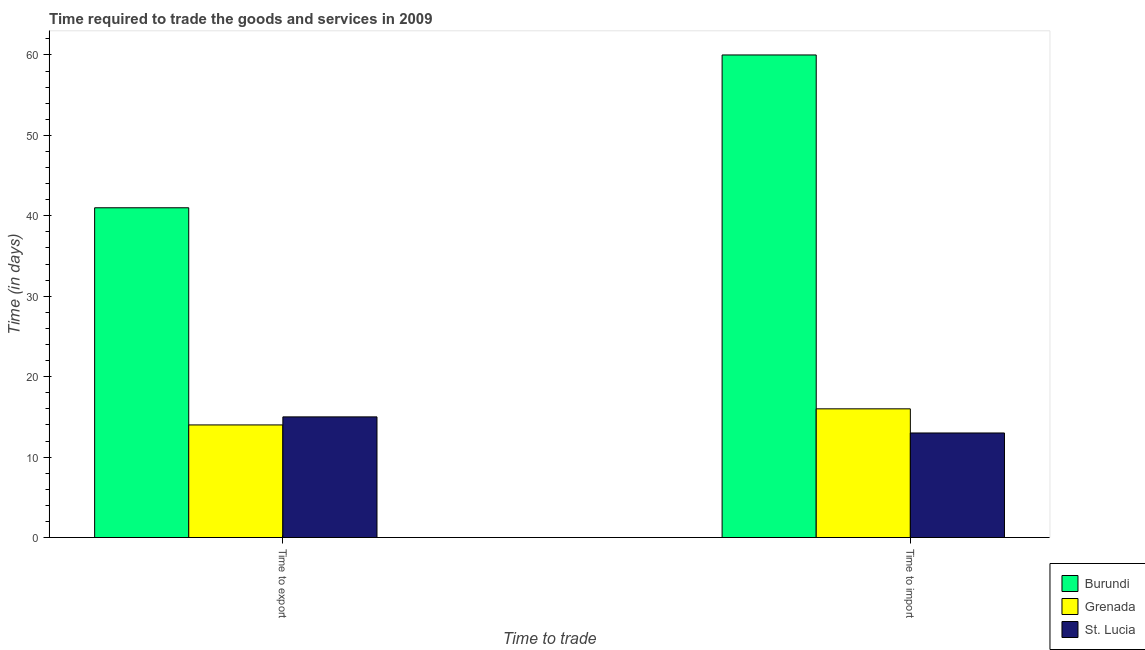How many different coloured bars are there?
Offer a terse response. 3. Are the number of bars on each tick of the X-axis equal?
Ensure brevity in your answer.  Yes. How many bars are there on the 2nd tick from the left?
Make the answer very short. 3. How many bars are there on the 2nd tick from the right?
Provide a short and direct response. 3. What is the label of the 2nd group of bars from the left?
Ensure brevity in your answer.  Time to import. What is the time to export in St. Lucia?
Offer a very short reply. 15. Across all countries, what is the maximum time to import?
Provide a succinct answer. 60. Across all countries, what is the minimum time to import?
Provide a succinct answer. 13. In which country was the time to export maximum?
Provide a succinct answer. Burundi. In which country was the time to export minimum?
Give a very brief answer. Grenada. What is the total time to export in the graph?
Provide a succinct answer. 70. What is the difference between the time to import in Burundi and that in St. Lucia?
Keep it short and to the point. 47. What is the difference between the time to export in Burundi and the time to import in Grenada?
Provide a short and direct response. 25. What is the average time to import per country?
Ensure brevity in your answer.  29.67. What is the difference between the time to import and time to export in Grenada?
Keep it short and to the point. 2. In how many countries, is the time to export greater than 16 days?
Provide a short and direct response. 1. What is the ratio of the time to import in Burundi to that in Grenada?
Make the answer very short. 3.75. Is the time to import in Burundi less than that in St. Lucia?
Provide a short and direct response. No. What does the 2nd bar from the left in Time to export represents?
Keep it short and to the point. Grenada. What does the 3rd bar from the right in Time to import represents?
Offer a very short reply. Burundi. How many bars are there?
Keep it short and to the point. 6. Are all the bars in the graph horizontal?
Keep it short and to the point. No. Where does the legend appear in the graph?
Offer a very short reply. Bottom right. How are the legend labels stacked?
Your answer should be compact. Vertical. What is the title of the graph?
Your answer should be very brief. Time required to trade the goods and services in 2009. Does "Seychelles" appear as one of the legend labels in the graph?
Offer a very short reply. No. What is the label or title of the X-axis?
Your answer should be very brief. Time to trade. What is the label or title of the Y-axis?
Ensure brevity in your answer.  Time (in days). What is the Time (in days) in Grenada in Time to export?
Provide a short and direct response. 14. What is the Time (in days) in St. Lucia in Time to import?
Give a very brief answer. 13. Across all Time to trade, what is the maximum Time (in days) of Grenada?
Ensure brevity in your answer.  16. Across all Time to trade, what is the maximum Time (in days) in St. Lucia?
Your answer should be very brief. 15. Across all Time to trade, what is the minimum Time (in days) in Burundi?
Ensure brevity in your answer.  41. Across all Time to trade, what is the minimum Time (in days) of Grenada?
Your answer should be very brief. 14. What is the total Time (in days) of Burundi in the graph?
Keep it short and to the point. 101. What is the total Time (in days) in St. Lucia in the graph?
Give a very brief answer. 28. What is the difference between the Time (in days) of Burundi in Time to export and that in Time to import?
Your answer should be compact. -19. What is the difference between the Time (in days) of Grenada in Time to export and that in Time to import?
Ensure brevity in your answer.  -2. What is the difference between the Time (in days) of Burundi in Time to export and the Time (in days) of St. Lucia in Time to import?
Make the answer very short. 28. What is the average Time (in days) of Burundi per Time to trade?
Your response must be concise. 50.5. What is the average Time (in days) of Grenada per Time to trade?
Give a very brief answer. 15. What is the difference between the Time (in days) of Burundi and Time (in days) of St. Lucia in Time to export?
Offer a very short reply. 26. What is the difference between the Time (in days) in Grenada and Time (in days) in St. Lucia in Time to export?
Ensure brevity in your answer.  -1. What is the difference between the Time (in days) of Burundi and Time (in days) of Grenada in Time to import?
Offer a terse response. 44. What is the difference between the Time (in days) in Burundi and Time (in days) in St. Lucia in Time to import?
Offer a very short reply. 47. What is the ratio of the Time (in days) in Burundi in Time to export to that in Time to import?
Keep it short and to the point. 0.68. What is the ratio of the Time (in days) in St. Lucia in Time to export to that in Time to import?
Provide a succinct answer. 1.15. What is the difference between the highest and the second highest Time (in days) in Grenada?
Your answer should be compact. 2. 